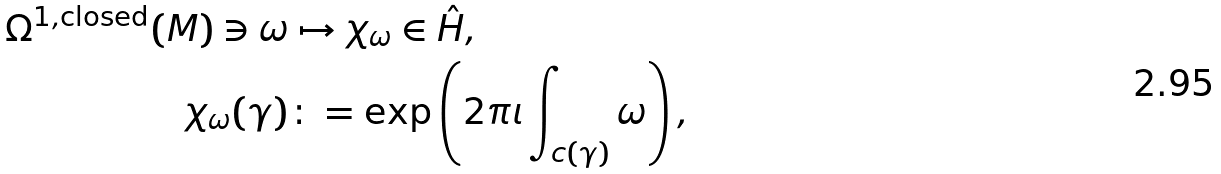Convert formula to latex. <formula><loc_0><loc_0><loc_500><loc_500>\Omega ^ { 1 , \text {closed} } ( M ) \ni \omega & \mapsto \chi _ { \omega } \in \hat { H } , \\ \chi _ { \omega } ( \gamma ) & \colon = \exp \left ( 2 \pi \imath \int _ { c ( \gamma ) } \omega \right ) ,</formula> 